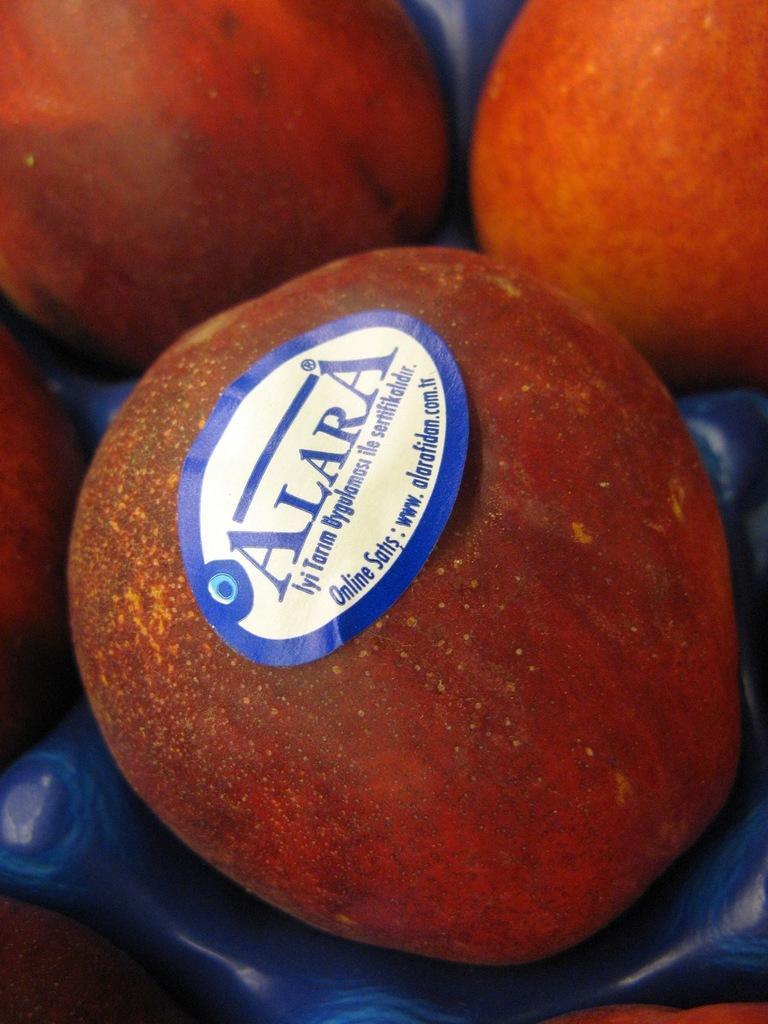In one or two sentences, can you explain what this image depicts? In this image, we can see apples. There is a sticker on the apple which is in the middle of the image. 